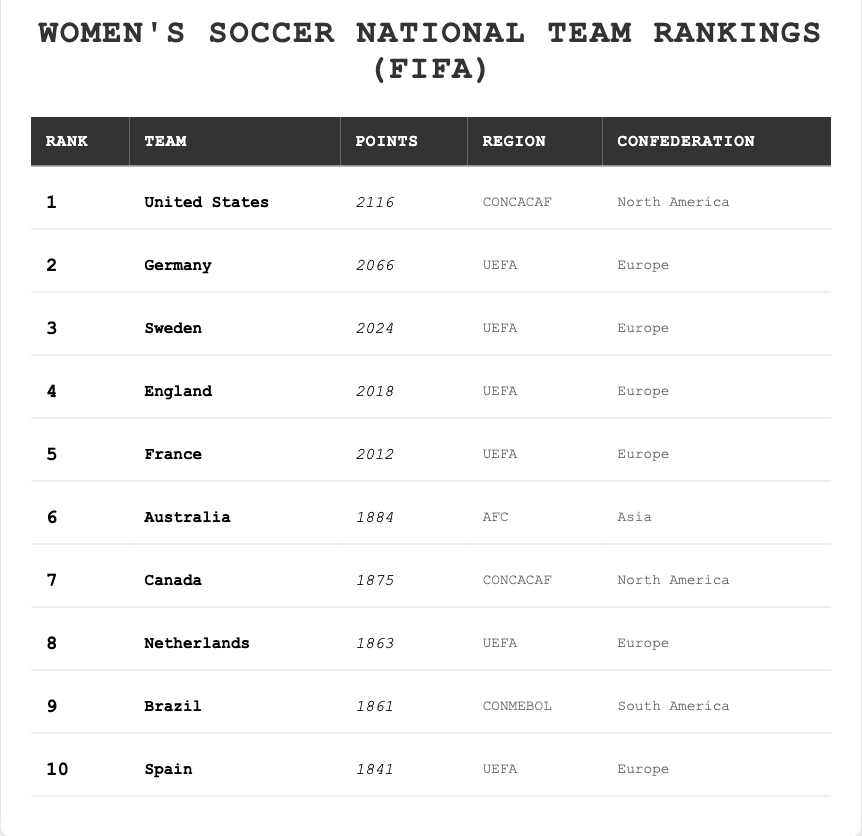What is the rank of the United States women's soccer team? The table lists the United States team at rank 1.
Answer: 1 How many points does the Germany women's soccer team have? From the table, Germany has 2066 points.
Answer: 2066 Which team ranks 5th in the women's soccer national team rankings? According to the table, France is in 5th place.
Answer: France Which confederation does Brazil belong to? The table indicates that Brazil is part of the CONMEBOL confederation.
Answer: CONMEBOL What is the average points scored by the top three teams? The points for the top three teams are 2116 (USA), 2066 (Germany), and 2024 (Sweden). Summing these gives 2116 + 2066 + 2024 = 6206. Dividing by 3 results in an average of 2068.67.
Answer: 2068.67 Is the Netherlands ranked higher than Canada? The Netherlands is ranked 8th while Canada is ranked 7th, indicating that Canada is ranked higher than the Netherlands.
Answer: No Which region has the most teams in the top 10? Count the teams in each region: UEFA (5 teams), CONCACAF (2 teams), AFC (1 team), and CONMEBOL (1 team). UEFA has the most teams.
Answer: UEFA What is the difference in points between the top-ranked team and the team ranked 10th? The United States has 2116 points and Spain has 1841 points. The difference is 2116 - 1841 = 275.
Answer: 275 How many teams from UEFA are in the top 10? The teams from UEFA listed are Germany, Sweden, England, France, Netherlands, and Spain, totaling 6 teams.
Answer: 6 Which two teams are closest in points? The points for Canada (1875) and Netherlands (1863) are closest, with a difference of 12 points.
Answer: Canada and Netherlands 